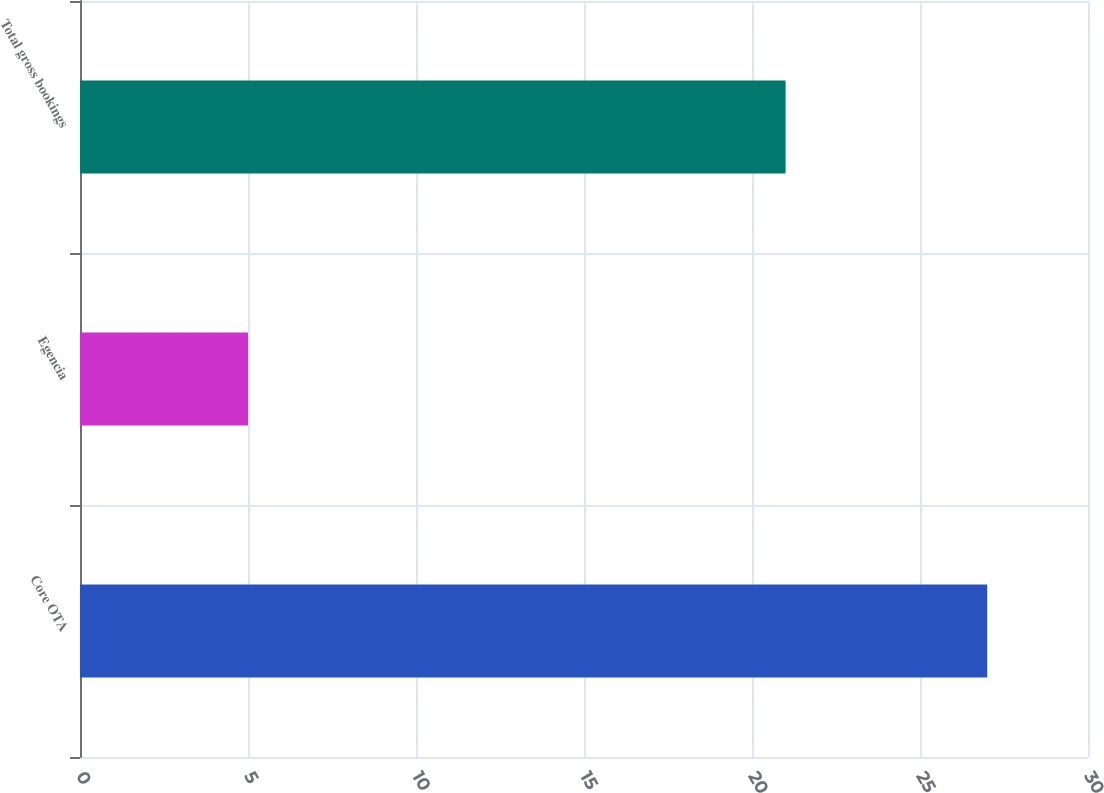Convert chart to OTSL. <chart><loc_0><loc_0><loc_500><loc_500><bar_chart><fcel>Core OTA<fcel>Egencia<fcel>Total gross bookings<nl><fcel>27<fcel>5<fcel>21<nl></chart> 